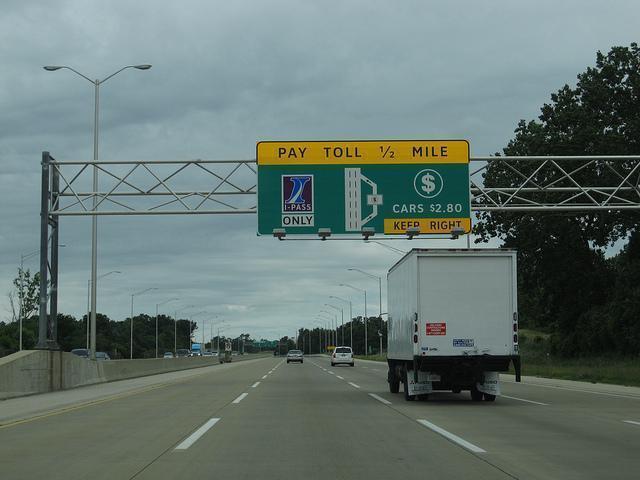What company handles the event that will happen in 1/2 mile?
Make your selection and explain in format: 'Answer: answer
Rationale: rationale.'
Options: Ez pass, secret service, ny mets, ny jets. Answer: ez pass.
Rationale: The company is ez pass. 